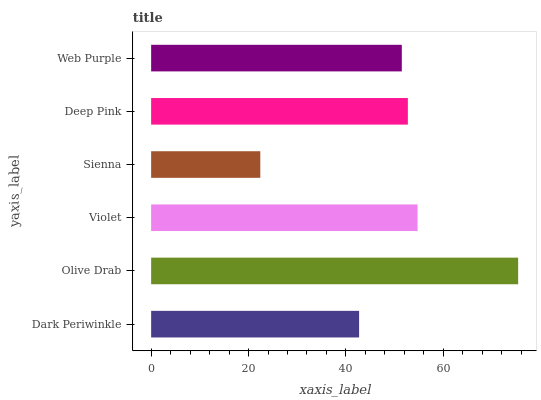Is Sienna the minimum?
Answer yes or no. Yes. Is Olive Drab the maximum?
Answer yes or no. Yes. Is Violet the minimum?
Answer yes or no. No. Is Violet the maximum?
Answer yes or no. No. Is Olive Drab greater than Violet?
Answer yes or no. Yes. Is Violet less than Olive Drab?
Answer yes or no. Yes. Is Violet greater than Olive Drab?
Answer yes or no. No. Is Olive Drab less than Violet?
Answer yes or no. No. Is Deep Pink the high median?
Answer yes or no. Yes. Is Web Purple the low median?
Answer yes or no. Yes. Is Olive Drab the high median?
Answer yes or no. No. Is Violet the low median?
Answer yes or no. No. 